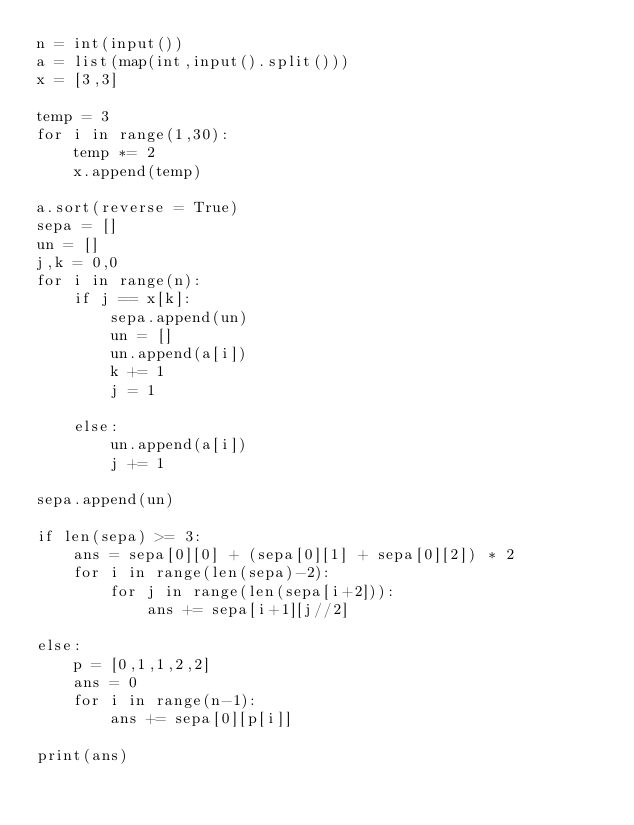Convert code to text. <code><loc_0><loc_0><loc_500><loc_500><_Python_>n = int(input())
a = list(map(int,input().split()))
x = [3,3]

temp = 3
for i in range(1,30):
    temp *= 2
    x.append(temp)
    
a.sort(reverse = True)
sepa = []
un = []
j,k = 0,0
for i in range(n):
    if j == x[k]:
        sepa.append(un)
        un = []
        un.append(a[i])
        k += 1
        j = 1
        
    else:
        un.append(a[i])
        j += 1
        
sepa.append(un)

if len(sepa) >= 3:
    ans = sepa[0][0] + (sepa[0][1] + sepa[0][2]) * 2
    for i in range(len(sepa)-2):
        for j in range(len(sepa[i+2])):
            ans += sepa[i+1][j//2]
            
else:
    p = [0,1,1,2,2]
    ans = 0
    for i in range(n-1):
        ans += sepa[0][p[i]]
            
print(ans)</code> 